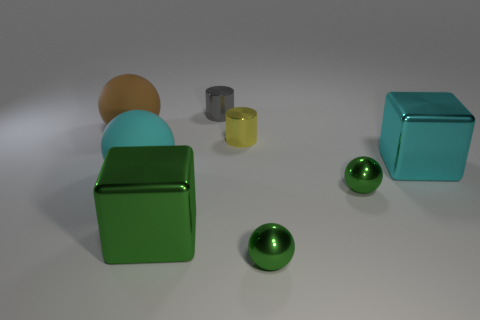Subtract 1 spheres. How many spheres are left? 3 Add 1 big brown spheres. How many objects exist? 9 Subtract all cylinders. How many objects are left? 6 Subtract 0 yellow balls. How many objects are left? 8 Subtract all tiny yellow objects. Subtract all small blue matte things. How many objects are left? 7 Add 4 tiny gray metallic objects. How many tiny gray metallic objects are left? 5 Add 7 tiny cylinders. How many tiny cylinders exist? 9 